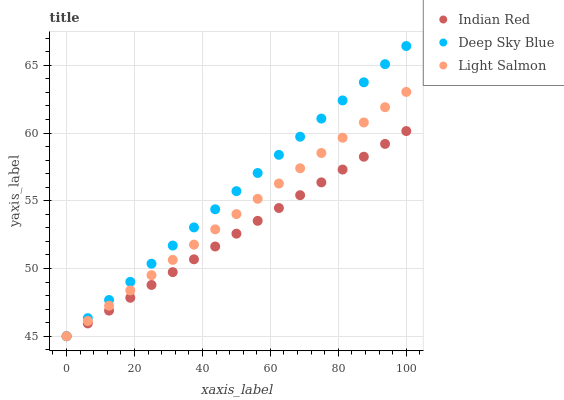Does Indian Red have the minimum area under the curve?
Answer yes or no. Yes. Does Deep Sky Blue have the maximum area under the curve?
Answer yes or no. Yes. Does Deep Sky Blue have the minimum area under the curve?
Answer yes or no. No. Does Indian Red have the maximum area under the curve?
Answer yes or no. No. Is Indian Red the smoothest?
Answer yes or no. Yes. Is Deep Sky Blue the roughest?
Answer yes or no. Yes. Is Deep Sky Blue the smoothest?
Answer yes or no. No. Is Indian Red the roughest?
Answer yes or no. No. Does Light Salmon have the lowest value?
Answer yes or no. Yes. Does Deep Sky Blue have the highest value?
Answer yes or no. Yes. Does Indian Red have the highest value?
Answer yes or no. No. Does Indian Red intersect Light Salmon?
Answer yes or no. Yes. Is Indian Red less than Light Salmon?
Answer yes or no. No. Is Indian Red greater than Light Salmon?
Answer yes or no. No. 